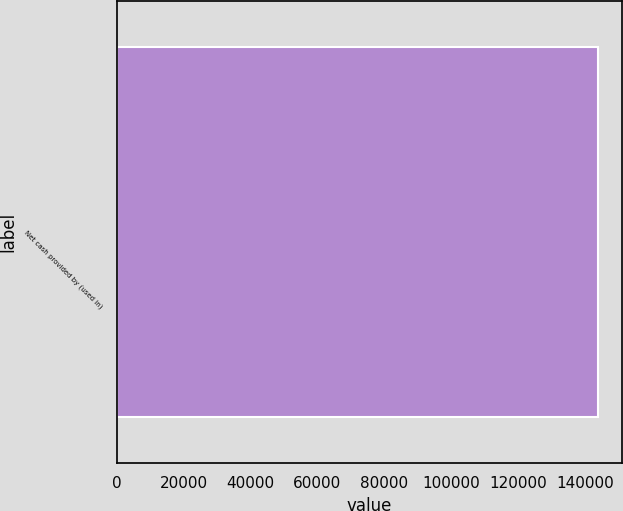<chart> <loc_0><loc_0><loc_500><loc_500><bar_chart><fcel>Net cash provided by (used in)<nl><fcel>143986<nl></chart> 